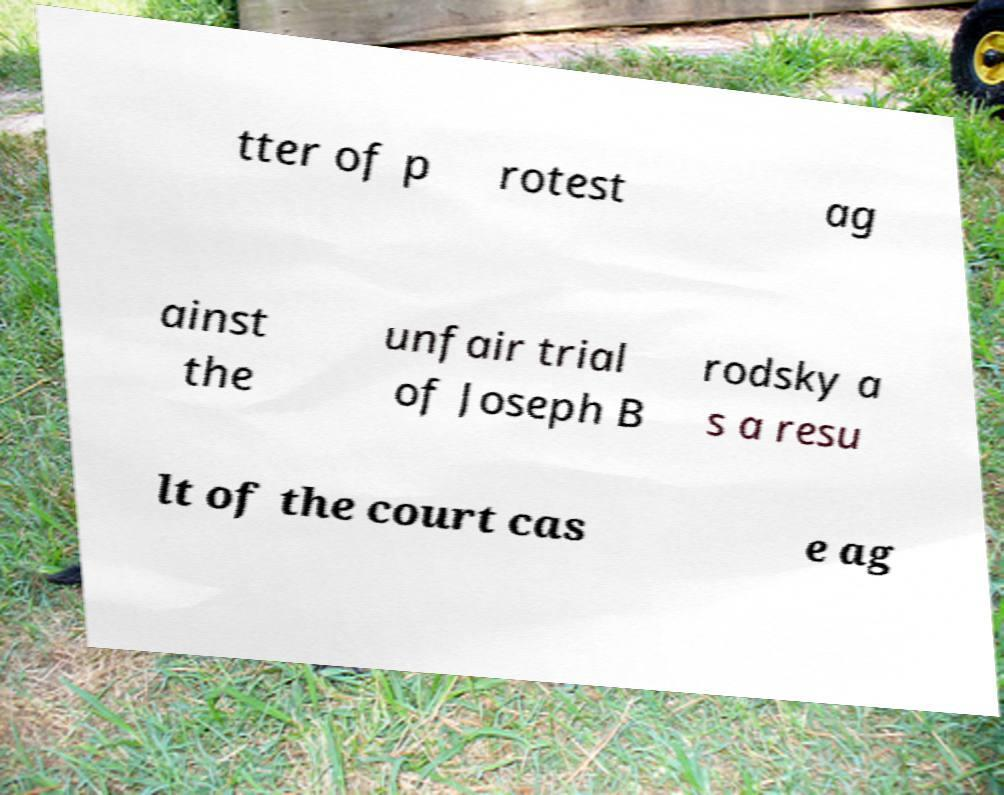Please read and relay the text visible in this image. What does it say? tter of p rotest ag ainst the unfair trial of Joseph B rodsky a s a resu lt of the court cas e ag 